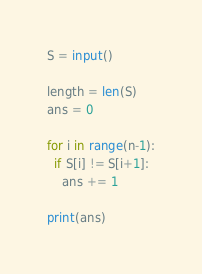Convert code to text. <code><loc_0><loc_0><loc_500><loc_500><_Python_>S = input()

length = len(S)
ans = 0

for i in range(n-1):
  if S[i] != S[i+1]:
    ans += 1

print(ans)</code> 